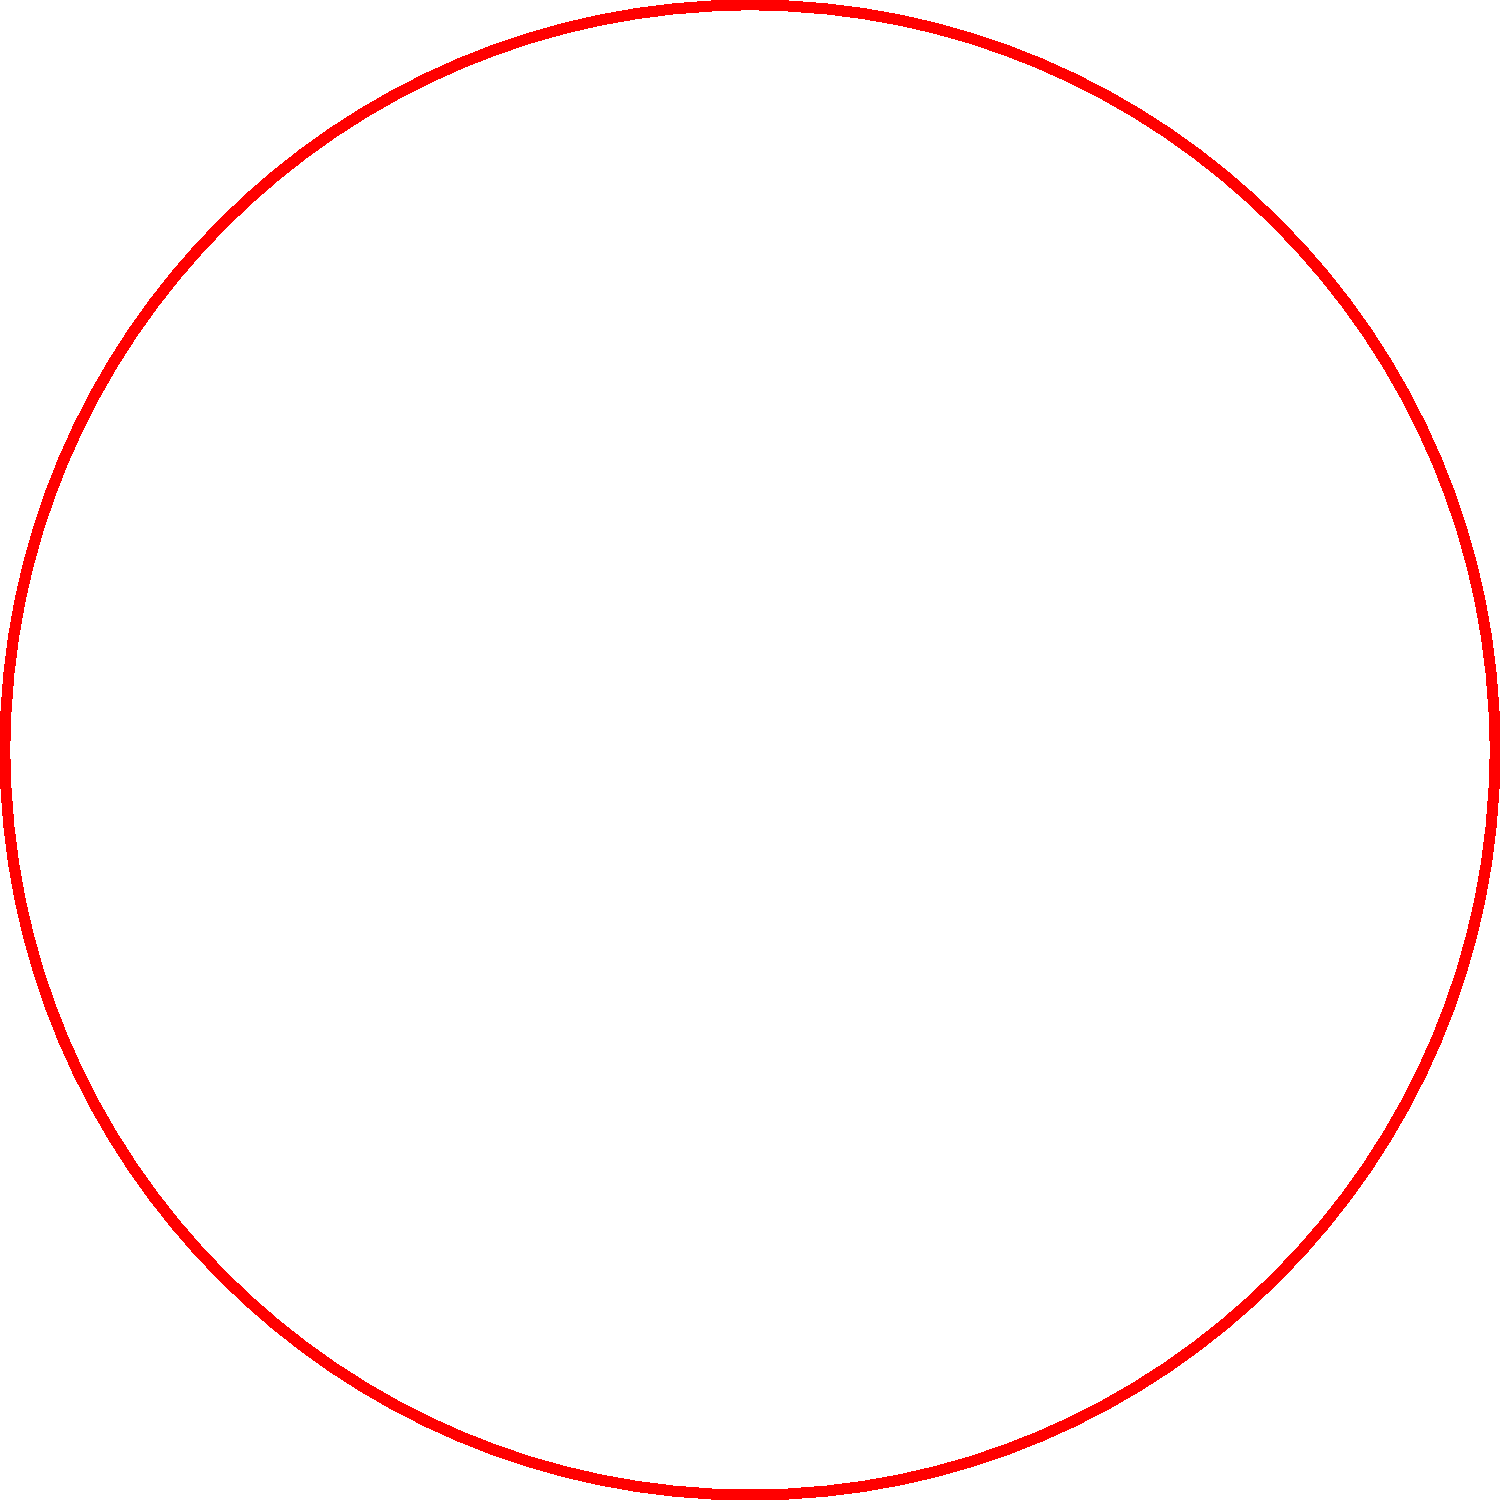Which type of Christmas light is typically associated with a warm, traditional look and is often used for creating a cozy atmosphere in indoor decorations? To answer this question, let's analyze each type of Christmas light shown in the image:

1. Light A: This is a round, globe-shaped light. It's a classic design often used in both indoor and outdoor decorations. The red color adds a warm, traditional feel.

2. Light B: This is a star-shaped light, often used as a tree topper or as an accent in outdoor displays. The green color is festive but not typically associated with a cozy indoor atmosphere.

3. Light C: This is a miniature tube light, commonly known as an icicle light. These are popular for outdoor eaves and roof decorations, mimicking hanging icicles.

4. Light D: This is an oval or flame-shaped light, often referred to as a C7 or C9 bulb depending on its size. These lights have a classic, vintage look and produce a warm glow.

Among these options, Light A (the round, globe-shaped light) is most typically associated with a warm, traditional look and is often used for creating a cozy atmosphere in indoor decorations. Its shape allows for a soft, diffused light that can create a warm ambiance in a room.

While Light D also has a traditional look, it's more commonly used for outdoor decorations due to its larger size and brighter output.
Answer: Light A (round, globe-shaped) 